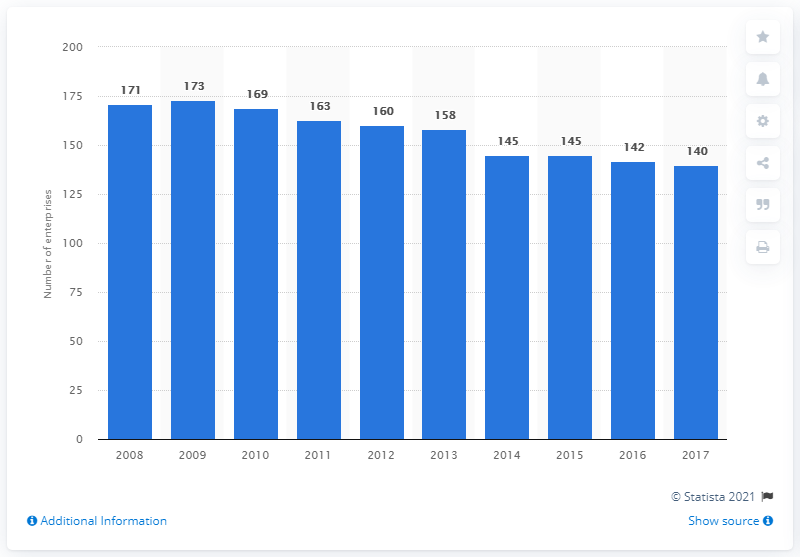List a handful of essential elements in this visual. In 2017, there were 140 enterprises in Croatia that were primarily engaged in manufacturing glass and glass products. 